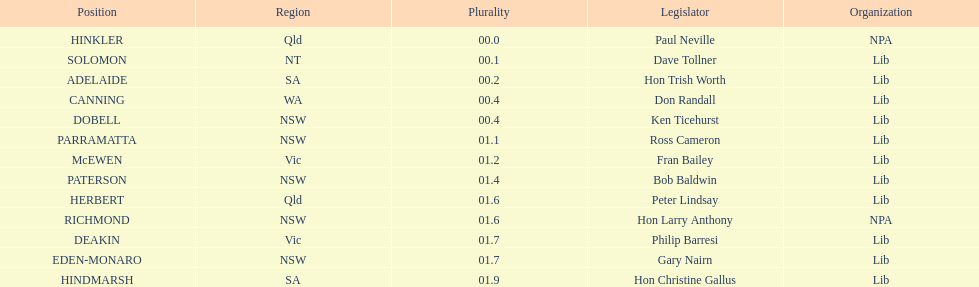What party had the most seats? Lib. 